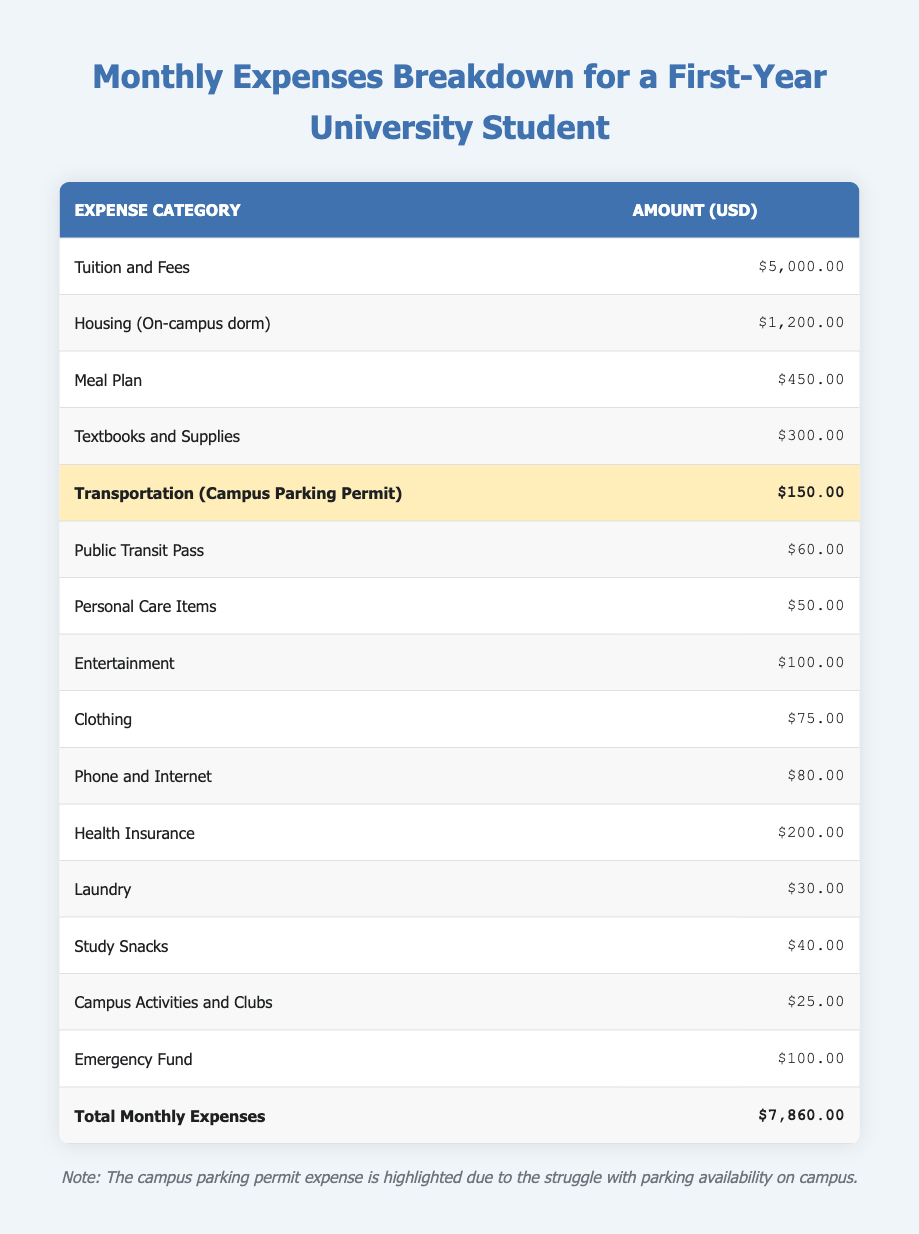What is the total amount spent on housing and meal plans? The amount for housing (on-campus dorm) is 1200 USD and the meal plan is 450 USD. Adding these two amounts gives 1200 + 450 = 1650.
Answer: 1650 What is the cost of the transportation category, including both campus parking and public transit? The campus parking permit costs 150 USD and the public transit pass costs 60 USD. Summing these amounts gives 150 + 60 = 210 USD.
Answer: 210 Is the expense for personal care items more than the expense for laundry? The expense for personal care items is 50 USD and the expense for laundry is 30 USD. Since 50 is greater than 30, the statement is true.
Answer: Yes What is the total amount spent on emergency fund and campus activities and clubs? The emergency fund is 100 USD and campus activities and clubs cost 25 USD. Adding these gives 100 + 25 = 125.
Answer: 125 What is the average spending on entertainment and clothing? The amount spent on entertainment is 100 USD and clothing is 75 USD. To find the average, we add these two amounts (100 + 75 = 175) and then divide by the number of categories (2): 175 / 2 = 87.5.
Answer: 87.5 What is the expense category with the highest cost? The highest cost in the table is the tuition and fees, which amounts to 5000 USD. This value clearly exceeds all other categories, making it the highest expense.
Answer: Tuition and Fees How much is spent on health insurance compared to the meal plan? Health insurance costs 200 USD while the meal plan costs 450 USD. Since 200 is less than 450, health insurance costs less than the meal plan.
Answer: Less What percentage of the total expenses is spent on books and supplies? The total expenses amount to 7860 USD and the textbooks and supplies cost 300 USD. To find the percentage, calculate (300 / 7860) * 100 = 3.81%.
Answer: 3.81% 